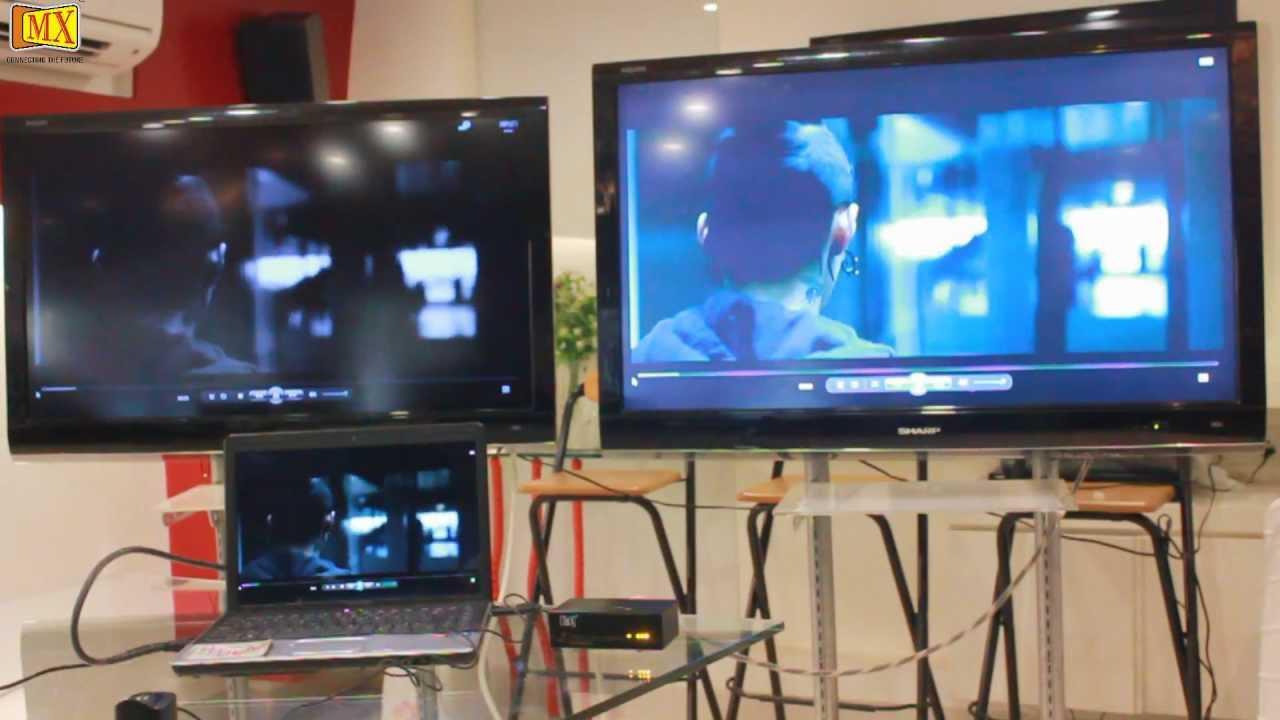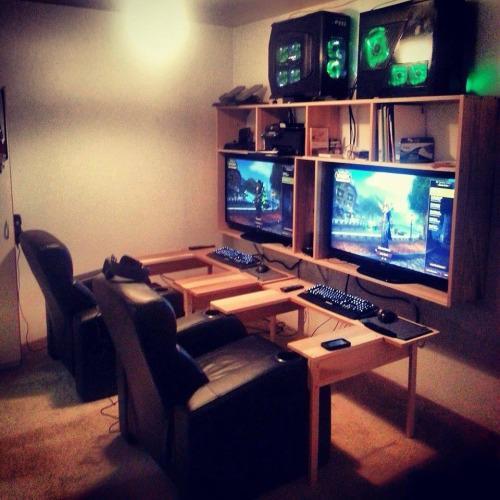The first image is the image on the left, the second image is the image on the right. Evaluate the accuracy of this statement regarding the images: "Here we have more than four monitors/televisions.". Is it true? Answer yes or no. Yes. 